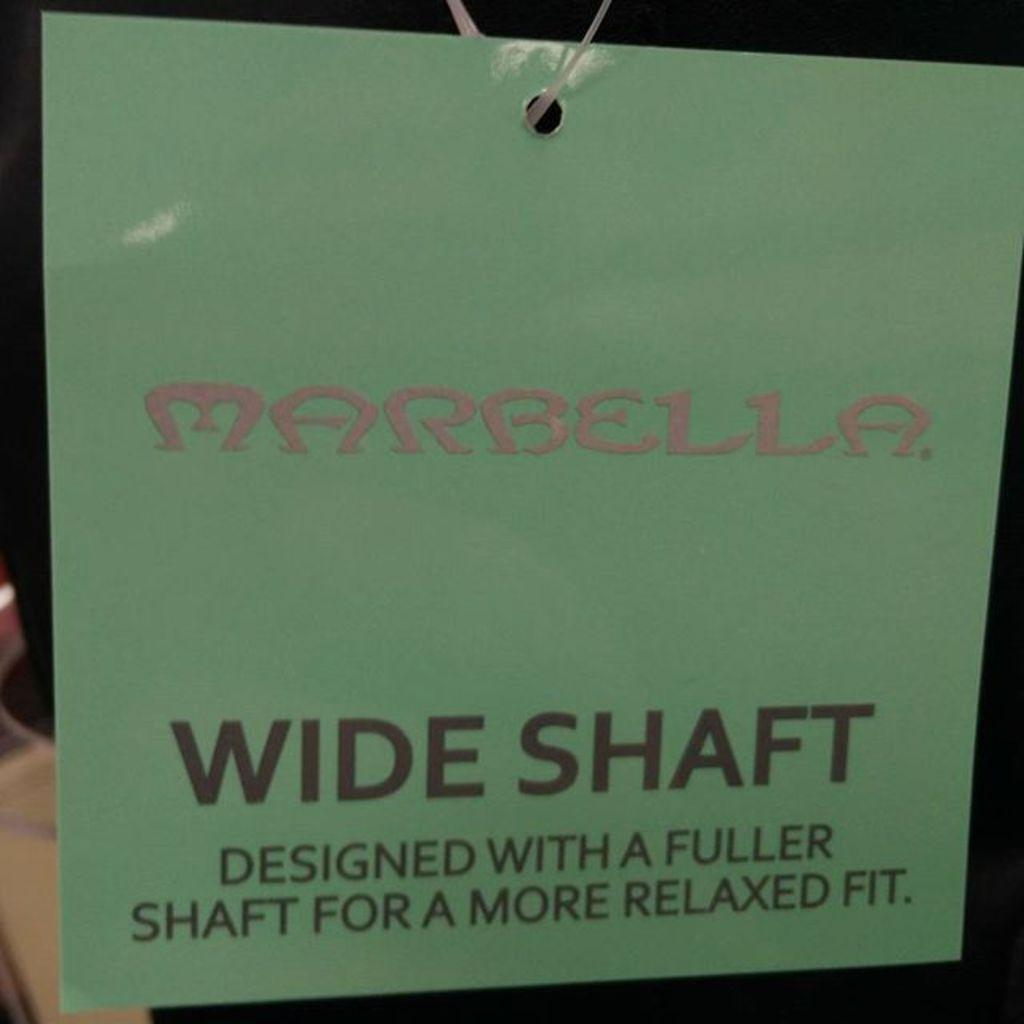<image>
Present a compact description of the photo's key features. A sign on a string that says wide shaft. 